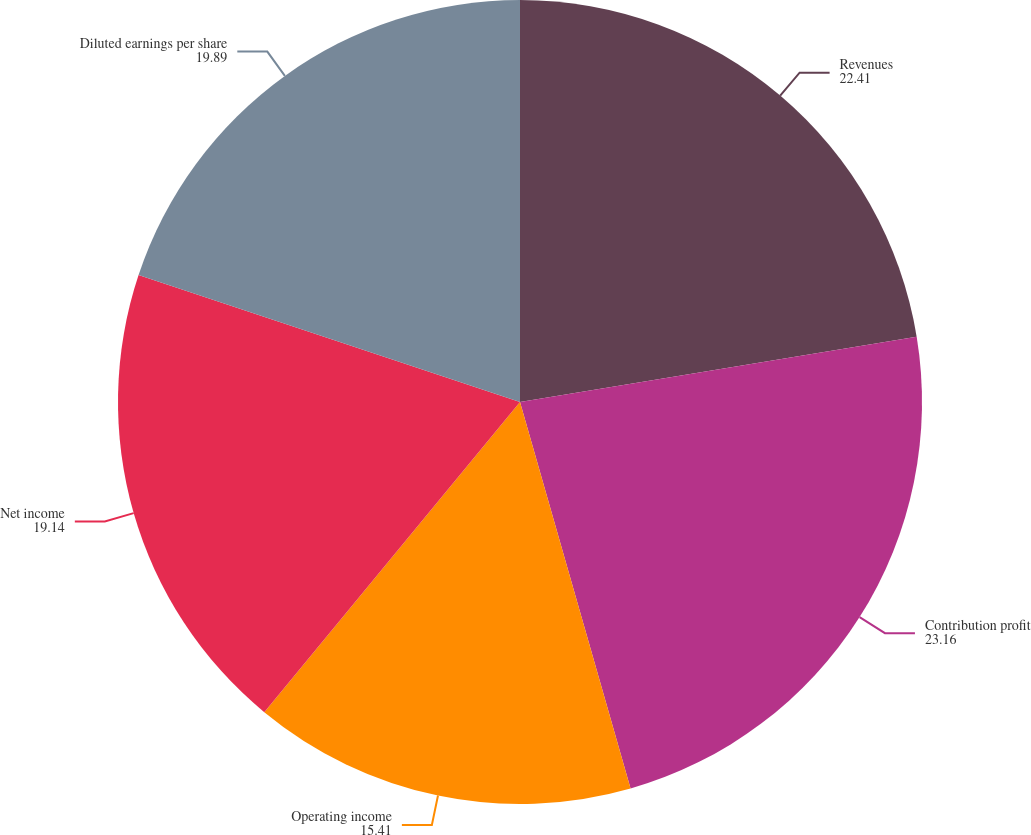Convert chart. <chart><loc_0><loc_0><loc_500><loc_500><pie_chart><fcel>Revenues<fcel>Contribution profit<fcel>Operating income<fcel>Net income<fcel>Diluted earnings per share<nl><fcel>22.41%<fcel>23.16%<fcel>15.41%<fcel>19.14%<fcel>19.89%<nl></chart> 